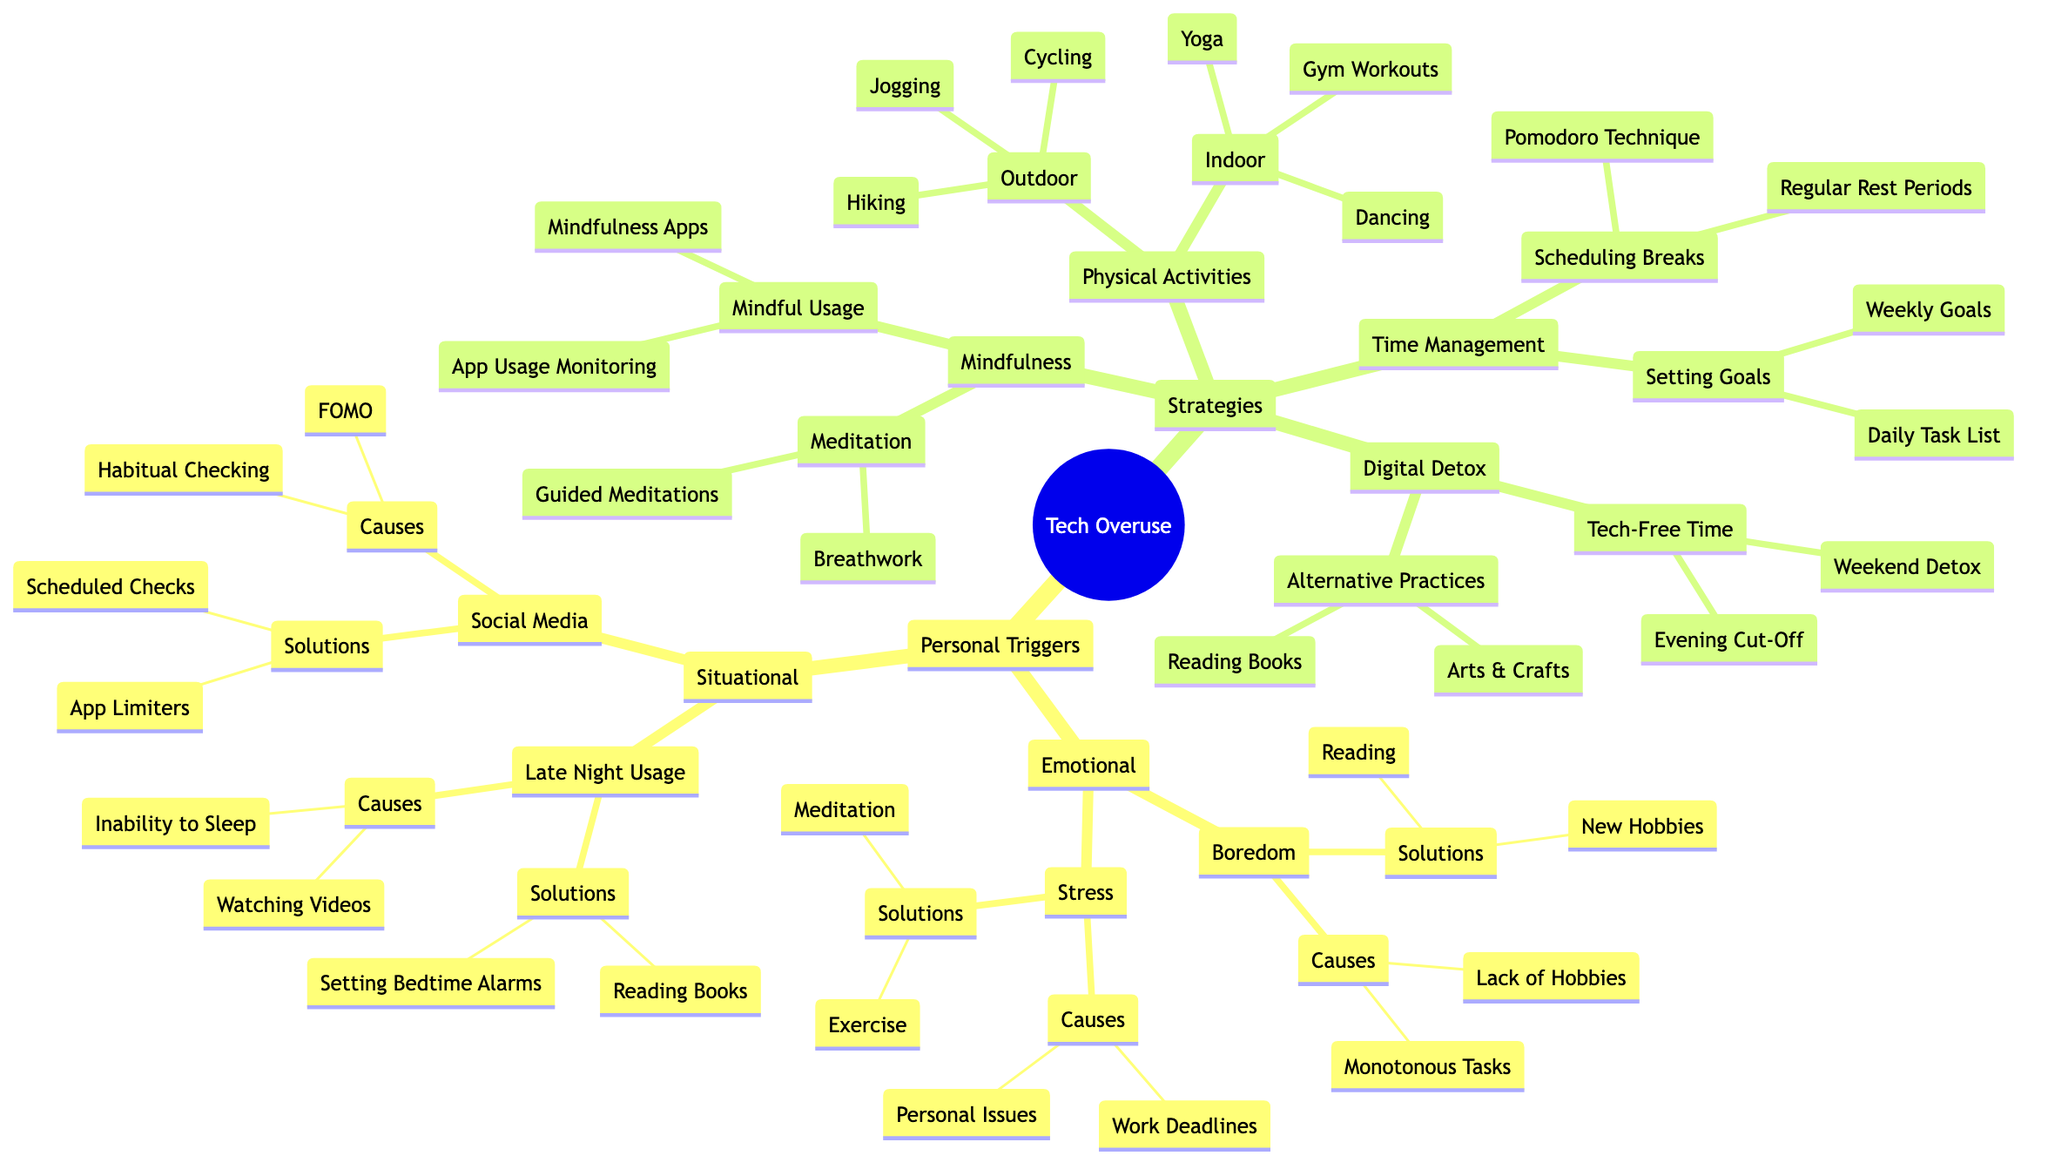What's the central topic of the mind map? The central topic is stated clearly at the root of the mind map. It indicates the main theme around which other branches are organized.
Answer: Personal Triggers and Strategies to Avoid Tech Overuse How many main branches are there in the diagram? The diagram is divided into two main branches which can be counted directly from the initial structure before the sub-branches.
Answer: 2 What are the solutions for stress? The solutions are listed directly under the "Stress" sub-branch, providing specific methods to mitigate the cause identified in that section.
Answer: Meditation, Exercise What emotional trigger is associated with boredom? The trigger is found directly in the Emotional branch under the Boredom sub-branch. It directly represents a type of emotional response leading to tech overuse.
Answer: Boredom Which strategies are recommended for physical activities? The recommended strategies are specified under the Physical Activities branch, indicating both outdoor and indoor activities as part of the overall approach to avoid tech overuse.
Answer: Outdoor Activities, Indoor Activities What is a solution to late night usage? This solution is detailed under the Late Night Usage sub-branch, indicating a practical approach to reduce tech overuse at night.
Answer: Reading Books, Setting Bedtime Alarms How are mindfulness practices structured in the diagram? The structure can be traced under the Strategies branch, specifically under Mindfulness Practices, where two key components are listed together, showing the organization and focus on mindfulness.
Answer: Meditation, Mindful Usage What causes habitual checking in social media? This cause is noted in the Social Media sub-branch, reflecting a common impulse that leads to increased tech usage.
Answer: Fear of Missing Out (FOMO), Habitual Checking What are two methods for scheduling breaks? These methods are located under the Scheduling Breaks sub-branch, clearly outlining techniques to implement structured breaks effectively.
Answer: Pomodoro Technique, Regular Rest Periods 